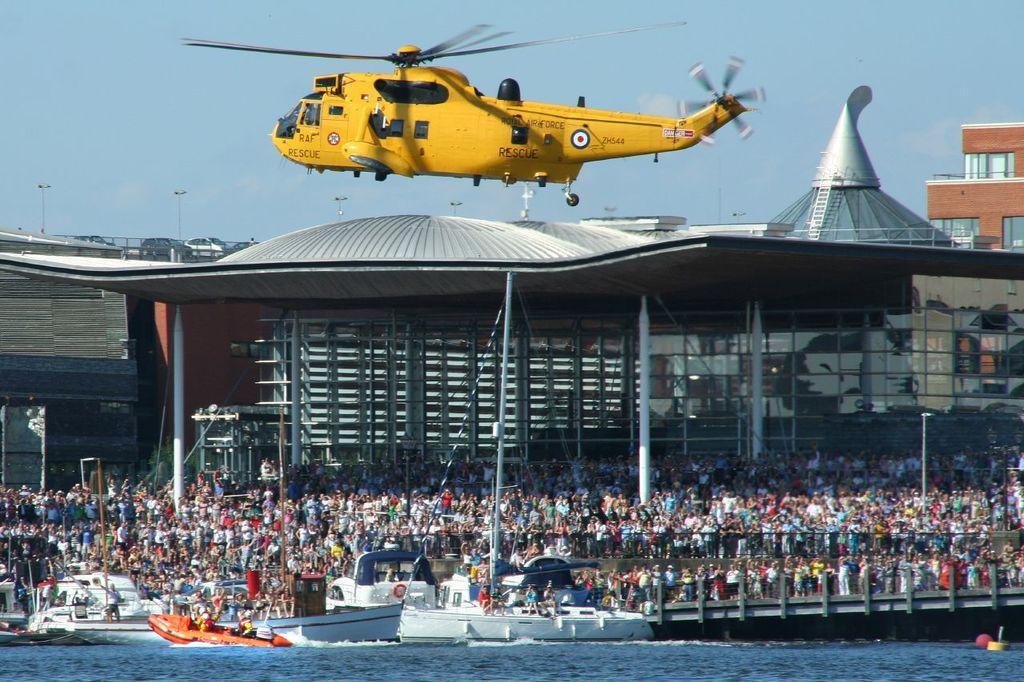In one or two sentences, can you explain what this image depicts? In this image I can see an aircraft which is yellow and black in color is flying in the air. I can see the water, few boats on the surface of the water and number of persons are standing on the ground. I can see few buildings , few vehicles and the sky in the background. 